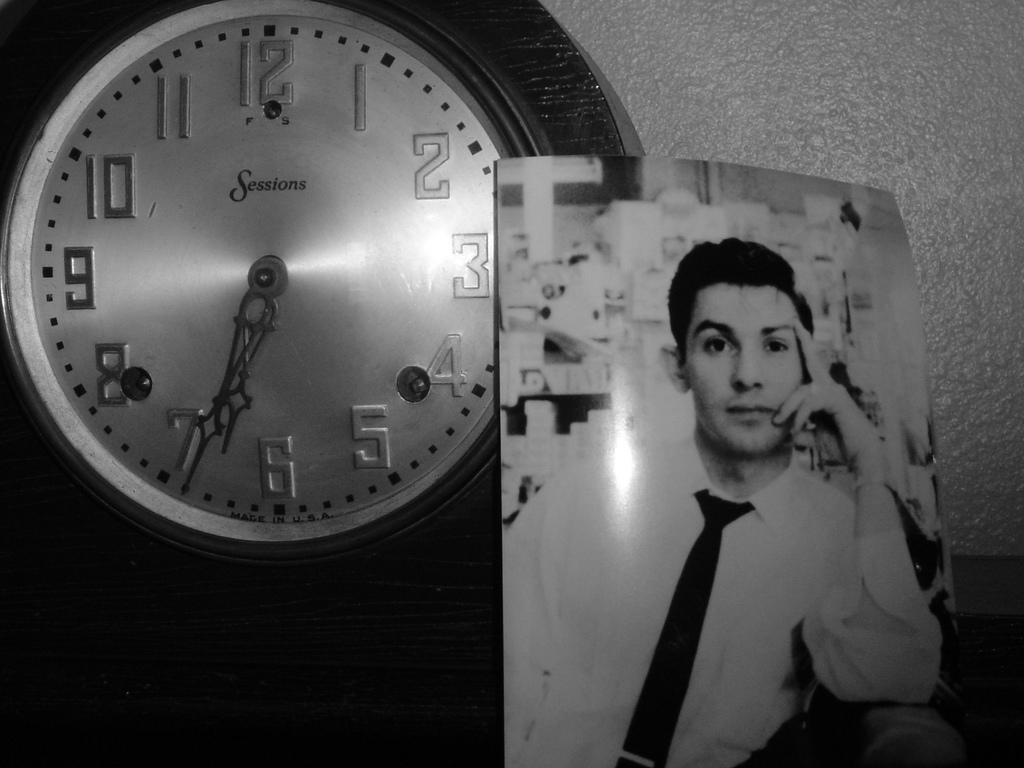What is the time on the clock?
Keep it short and to the point. 6:34. What brand of clock is showing?
Your response must be concise. Sessions. 